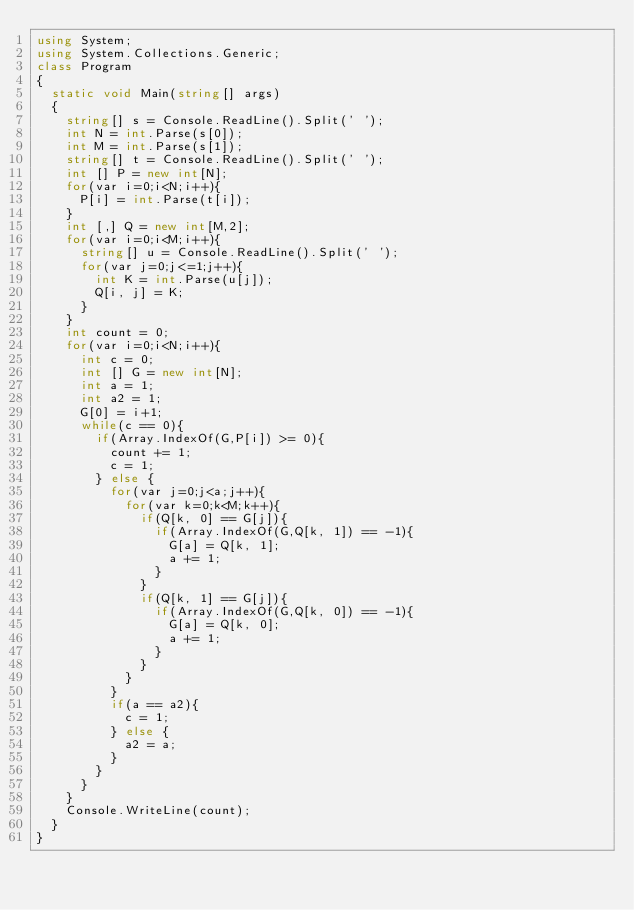Convert code to text. <code><loc_0><loc_0><loc_500><loc_500><_C#_>using System;
using System.Collections.Generic;
class Program
{
	static void Main(string[] args)
	{
		string[] s = Console.ReadLine().Split(' ');
		int N = int.Parse(s[0]);
		int M = int.Parse(s[1]);
		string[] t = Console.ReadLine().Split(' ');
		int [] P = new int[N];
		for(var i=0;i<N;i++){
			P[i] = int.Parse(t[i]);
		}
		int [,] Q = new int[M,2];
		for(var i=0;i<M;i++){
			string[] u = Console.ReadLine().Split(' ');
			for(var j=0;j<=1;j++){
				int K = int.Parse(u[j]);
				Q[i, j] = K;
			}
		}
		int count = 0;
		for(var i=0;i<N;i++){
			int c = 0;
			int [] G = new int[N];
			int a = 1;
			int a2 = 1;
			G[0] = i+1;
			while(c == 0){
				if(Array.IndexOf(G,P[i]) >= 0){
					count += 1;
					c = 1;
				} else {
					for(var j=0;j<a;j++){
						for(var k=0;k<M;k++){
							if(Q[k, 0] == G[j]){
								if(Array.IndexOf(G,Q[k, 1]) == -1){
									G[a] = Q[k, 1];
									a += 1;
								}
							}
							if(Q[k, 1] == G[j]){
								if(Array.IndexOf(G,Q[k, 0]) == -1){
									G[a] = Q[k, 0];
									a += 1;
								}
							}
						}
					}
					if(a == a2){
						c = 1;
					} else {
						a2 = a;
					}
				}
			}
		}
		Console.WriteLine(count);
	}
}</code> 